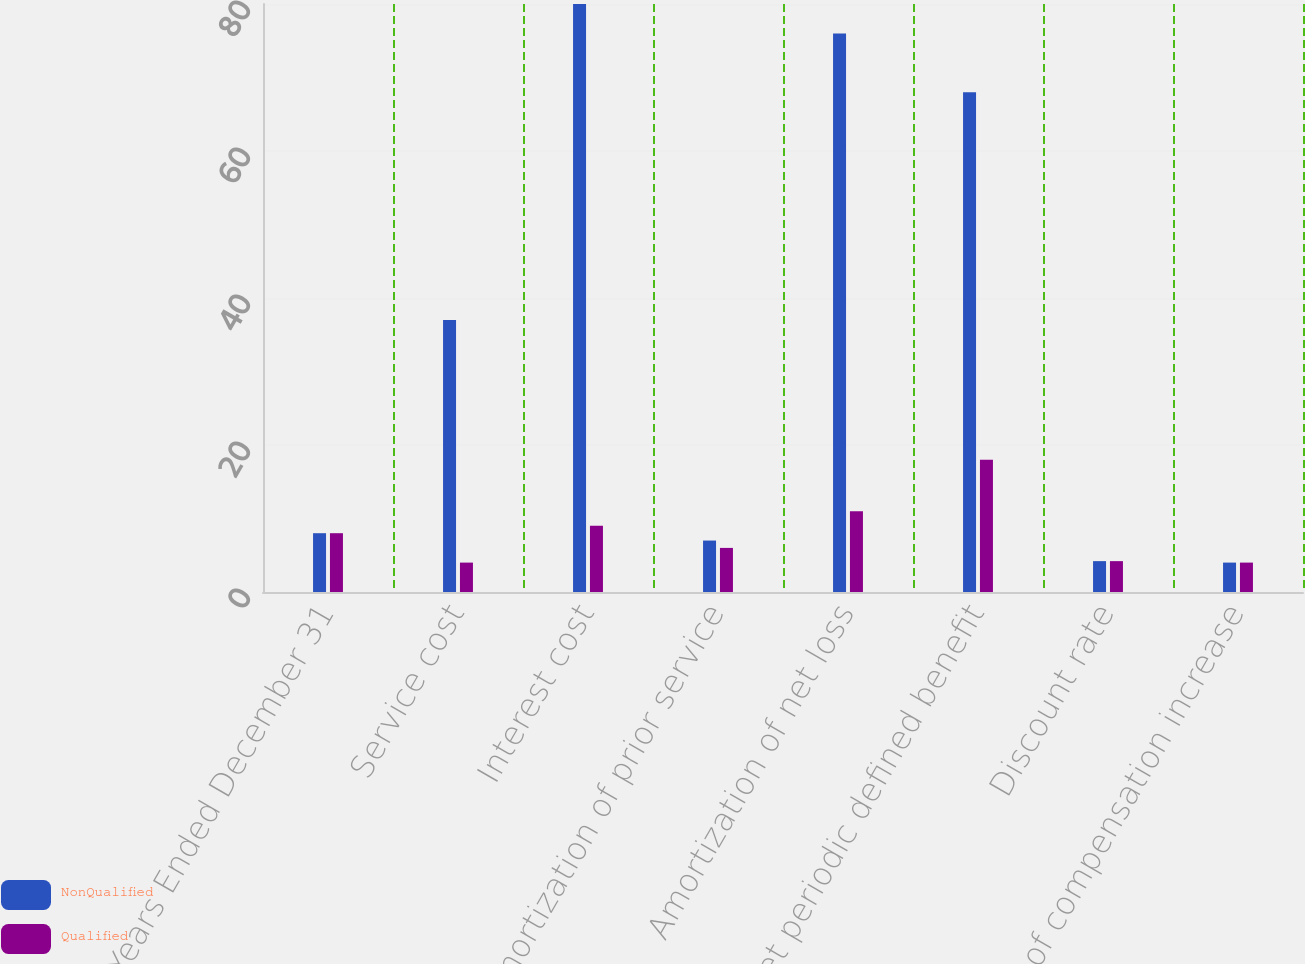<chart> <loc_0><loc_0><loc_500><loc_500><stacked_bar_chart><ecel><fcel>Years Ended December 31<fcel>Service cost<fcel>Interest cost<fcel>Amortization of prior service<fcel>Amortization of net loss<fcel>Net periodic defined benefit<fcel>Discount rate<fcel>Rate of compensation increase<nl><fcel>NonQualified<fcel>8<fcel>37<fcel>80<fcel>7<fcel>76<fcel>68<fcel>4.2<fcel>4<nl><fcel>Qualified<fcel>8<fcel>4<fcel>9<fcel>6<fcel>11<fcel>18<fcel>4.2<fcel>4<nl></chart> 